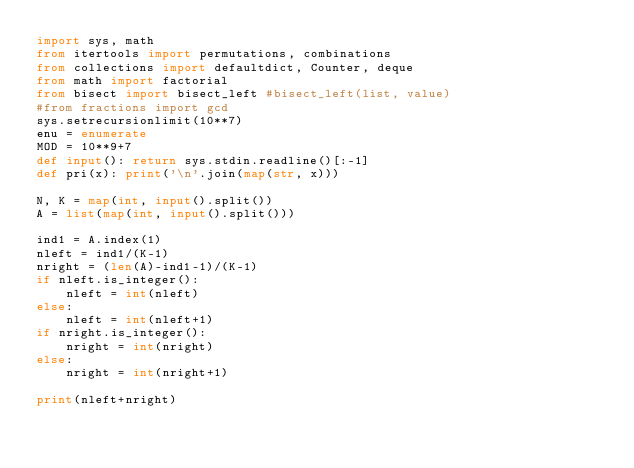<code> <loc_0><loc_0><loc_500><loc_500><_Python_>import sys, math
from itertools import permutations, combinations
from collections import defaultdict, Counter, deque
from math import factorial
from bisect import bisect_left #bisect_left(list, value)
#from fractions import gcd
sys.setrecursionlimit(10**7)
enu = enumerate
MOD = 10**9+7
def input(): return sys.stdin.readline()[:-1]
def pri(x): print('\n'.join(map(str, x)))

N, K = map(int, input().split())
A = list(map(int, input().split()))

ind1 = A.index(1)
nleft = ind1/(K-1)
nright = (len(A)-ind1-1)/(K-1)
if nleft.is_integer():
    nleft = int(nleft)
else:
    nleft = int(nleft+1)
if nright.is_integer():
    nright = int(nright)
else:
    nright = int(nright+1)

print(nleft+nright)
</code> 